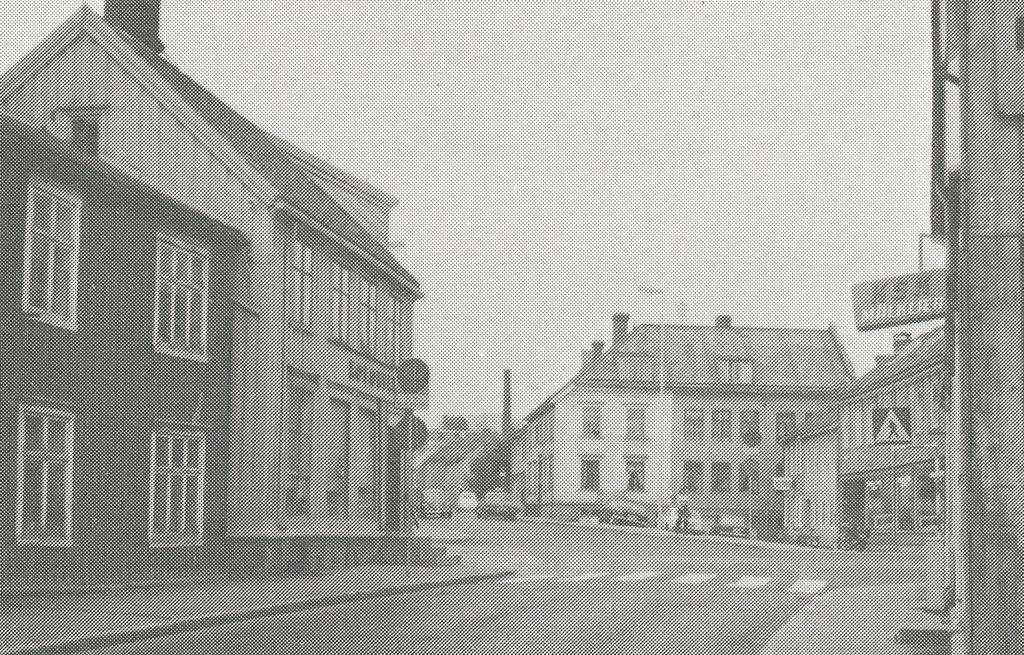What type of structures can be seen in the image? There are buildings in the image. What else is present in the image besides buildings? There are vehicles and boards with text in the image. Are there any plants growing on the boards with text in the image? There is no mention of plants in the image; it only features buildings, vehicles, and boards with text. 